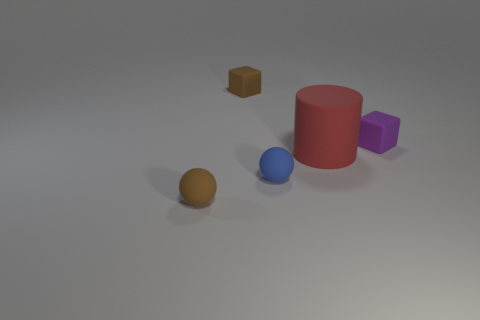What can the arrangement of these objects tell us? The spatial arrangement of the objects could represent a study in geometry or proportion, showcasing various shapes and sizes in relation to each other. The composition is balanced yet dynamic, suggesting an intentional placement for visual appeal or for comparing physical properties such as size and color. 